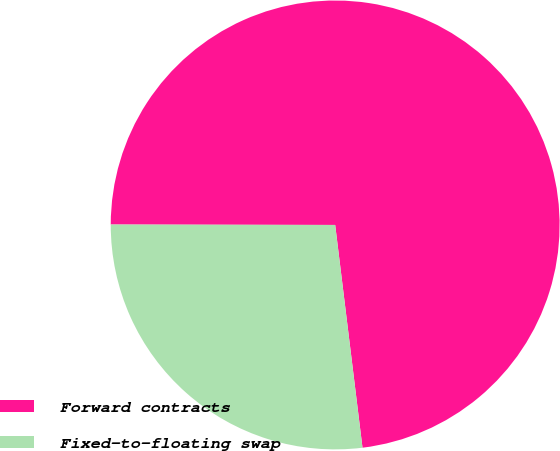Convert chart to OTSL. <chart><loc_0><loc_0><loc_500><loc_500><pie_chart><fcel>Forward contracts<fcel>Fixed-to-floating swap<nl><fcel>73.03%<fcel>26.97%<nl></chart> 